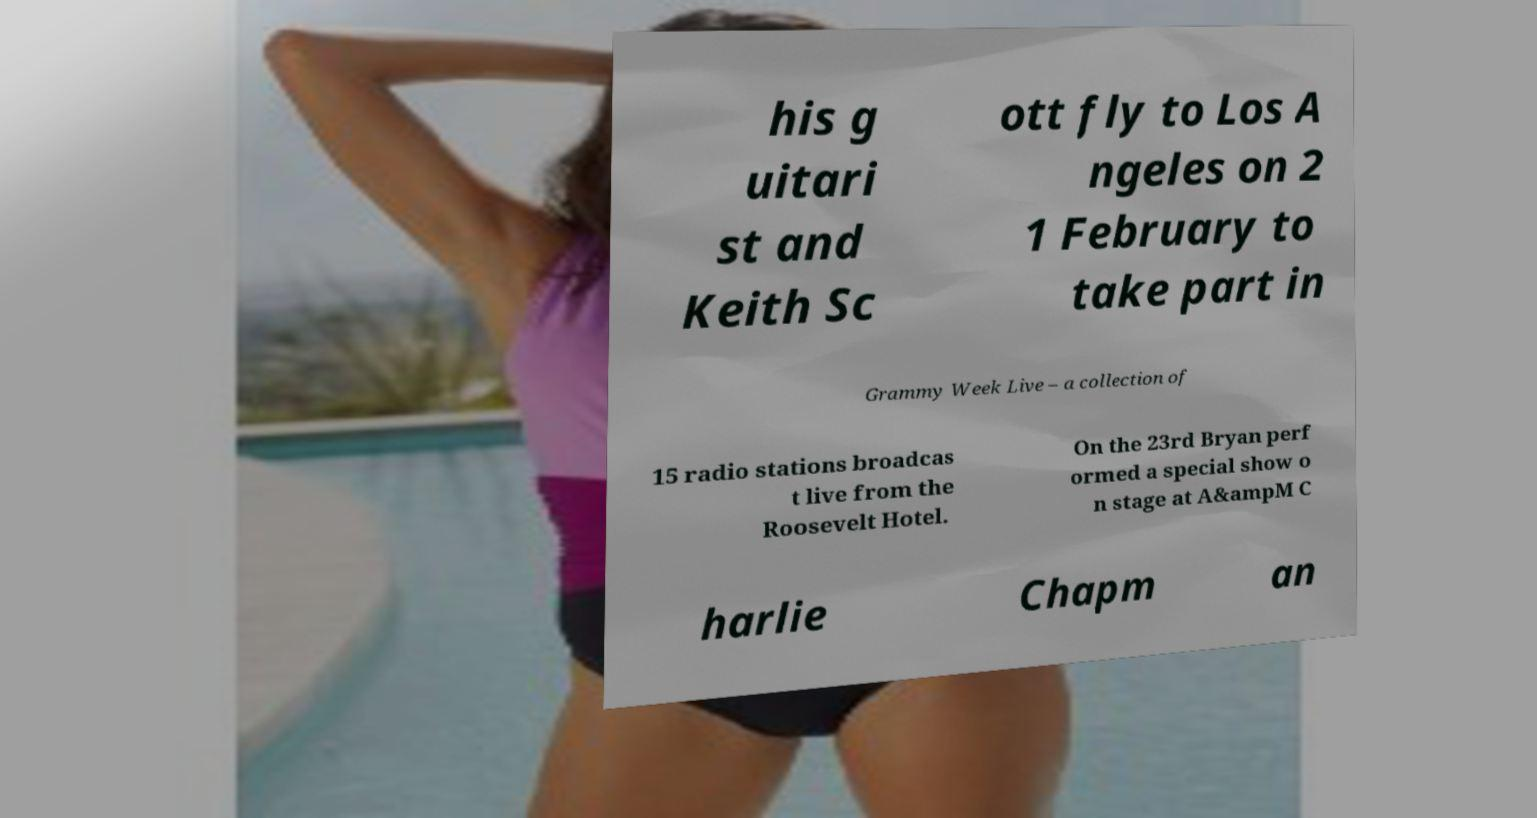Could you assist in decoding the text presented in this image and type it out clearly? his g uitari st and Keith Sc ott fly to Los A ngeles on 2 1 February to take part in Grammy Week Live – a collection of 15 radio stations broadcas t live from the Roosevelt Hotel. On the 23rd Bryan perf ormed a special show o n stage at A&ampM C harlie Chapm an 